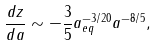<formula> <loc_0><loc_0><loc_500><loc_500>\frac { d z } { d a } \sim - \frac { 3 } { 5 } a _ { e q } ^ { - 3 / 2 0 } a ^ { - 8 / 5 } ,</formula> 